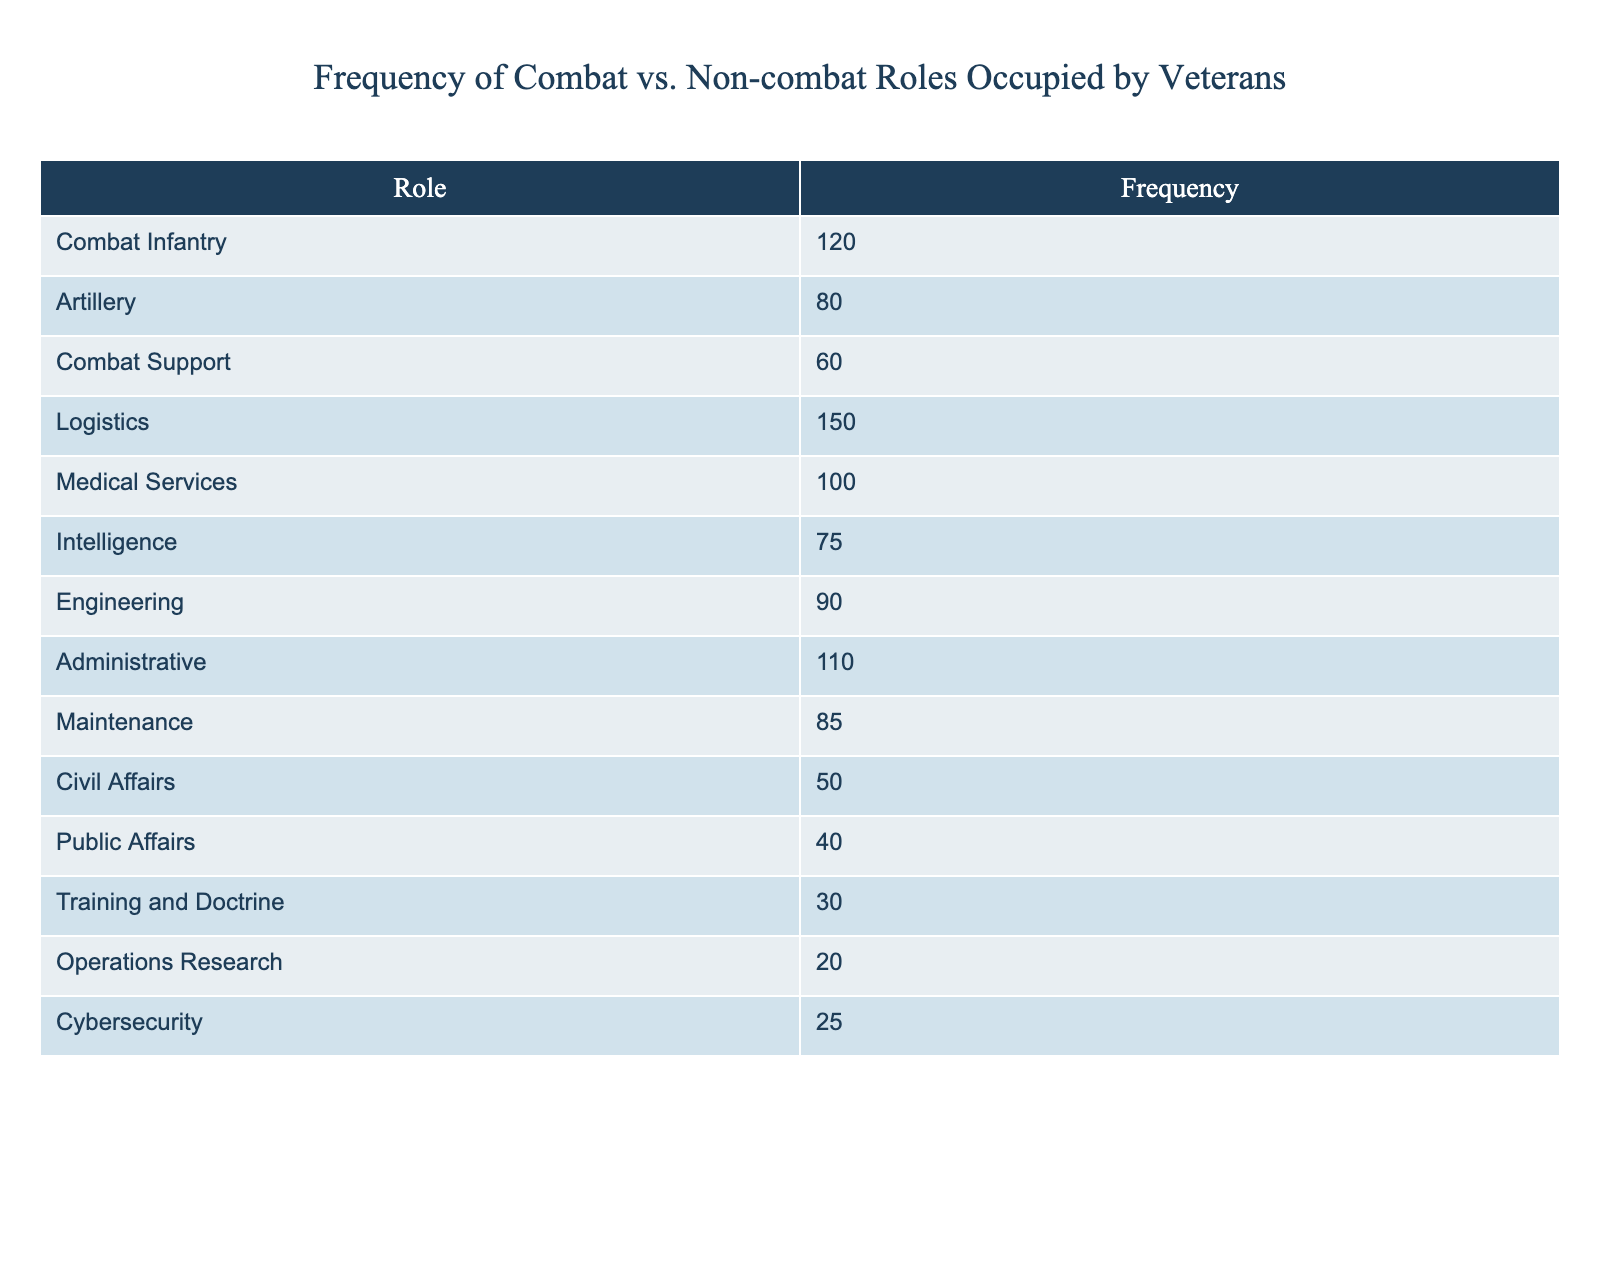What is the frequency of Engineering roles occupied by veterans? The table lists the frequency of various roles occupied by veterans, and specifically for Engineering, the frequency is directly mentioned.
Answer: 90 How many veterans served in Non-combat roles? Non-combat roles include Logistics, Medical Services, Administrative, Maintenance, Civil Affairs, Public Affairs, Training and Doctrine, Operations Research, and Cybersecurity. Adding those frequencies gives: 150 + 100 + 110 + 85 + 50 + 40 + 30 + 20 + 25 = 610.
Answer: 610 What is the total frequency of Combat roles? Combat roles include Combat Infantry, Artillery, Combat Support. Adding their frequencies: 120 + 80 + 60 = 260.
Answer: 260 Is the frequency of Public Affairs higher than that of Civil Affairs? The frequency of Public Affairs is 40, and the frequency of Civil Affairs is 50. Since 40 is less than 50, the statement is false.
Answer: No What role has the highest frequency among the listed categories? By comparing all the frequencies, Logistics has the highest frequency at 150.
Answer: Logistics What is the average frequency of all roles listed in the table? There are 14 roles listed in the table. The total frequencies are: 120 + 80 + 60 + 150 + 100 + 75 + 90 + 110 + 85 + 50 + 40 + 30 + 20 + 25 = 1,015. Thus, the average is 1,015 / 14 = 72.5.
Answer: 72.5 How many more veterans served in Logistics than in Cybersecurity? The frequency of Logistics is 150 and that of Cybersecurity is 25. The difference is 150 - 25 = 125.
Answer: 125 Which role has a frequency closest to the median of all roles? To find the median frequency, the list of frequencies sorted is: 20, 25, 30, 40, 50, 60, 75, 80, 85, 90, 100, 110, 120, 150. The median is the average of the 7th and 8th frequencies: (75 + 80) / 2 = 77.5, which is closest to the frequency of 80 for Artillery.
Answer: Artillery How many roles have a frequency greater than 100? Looking at the table, the roles with frequencies greater than 100 are Logistics (150), Medical Services (100), and Administrative (110), totaling three roles.
Answer: 3 